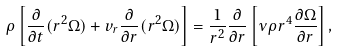<formula> <loc_0><loc_0><loc_500><loc_500>\rho \left [ \frac { \partial } { \partial t } ( r ^ { 2 } \Omega ) + v _ { r } \frac { \partial } { \partial r } ( r ^ { 2 } \Omega ) \right ] = \frac { 1 } { r ^ { 2 } } \frac { \partial } { \partial r } \left [ \nu \rho r ^ { 4 } \frac { \partial \Omega } { \partial r } \right ] ,</formula> 